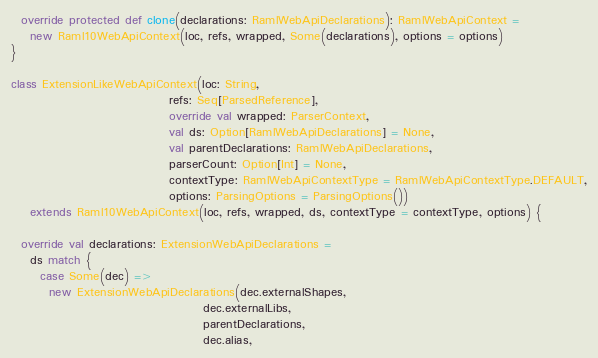<code> <loc_0><loc_0><loc_500><loc_500><_Scala_>  override protected def clone(declarations: RamlWebApiDeclarations): RamlWebApiContext =
    new Raml10WebApiContext(loc, refs, wrapped, Some(declarations), options = options)
}

class ExtensionLikeWebApiContext(loc: String,
                                 refs: Seq[ParsedReference],
                                 override val wrapped: ParserContext,
                                 val ds: Option[RamlWebApiDeclarations] = None,
                                 val parentDeclarations: RamlWebApiDeclarations,
                                 parserCount: Option[Int] = None,
                                 contextType: RamlWebApiContextType = RamlWebApiContextType.DEFAULT,
                                 options: ParsingOptions = ParsingOptions())
    extends Raml10WebApiContext(loc, refs, wrapped, ds, contextType = contextType, options) {

  override val declarations: ExtensionWebApiDeclarations =
    ds match {
      case Some(dec) =>
        new ExtensionWebApiDeclarations(dec.externalShapes,
                                        dec.externalLibs,
                                        parentDeclarations,
                                        dec.alias,</code> 